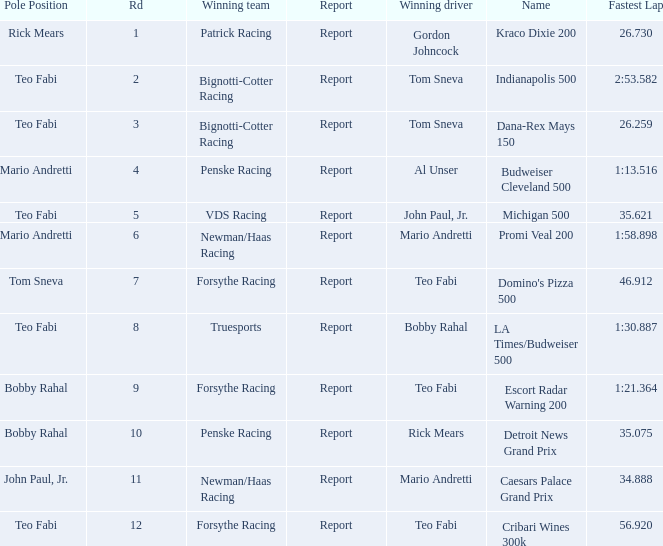Which Rd took place at the Indianapolis 500? 2.0. 